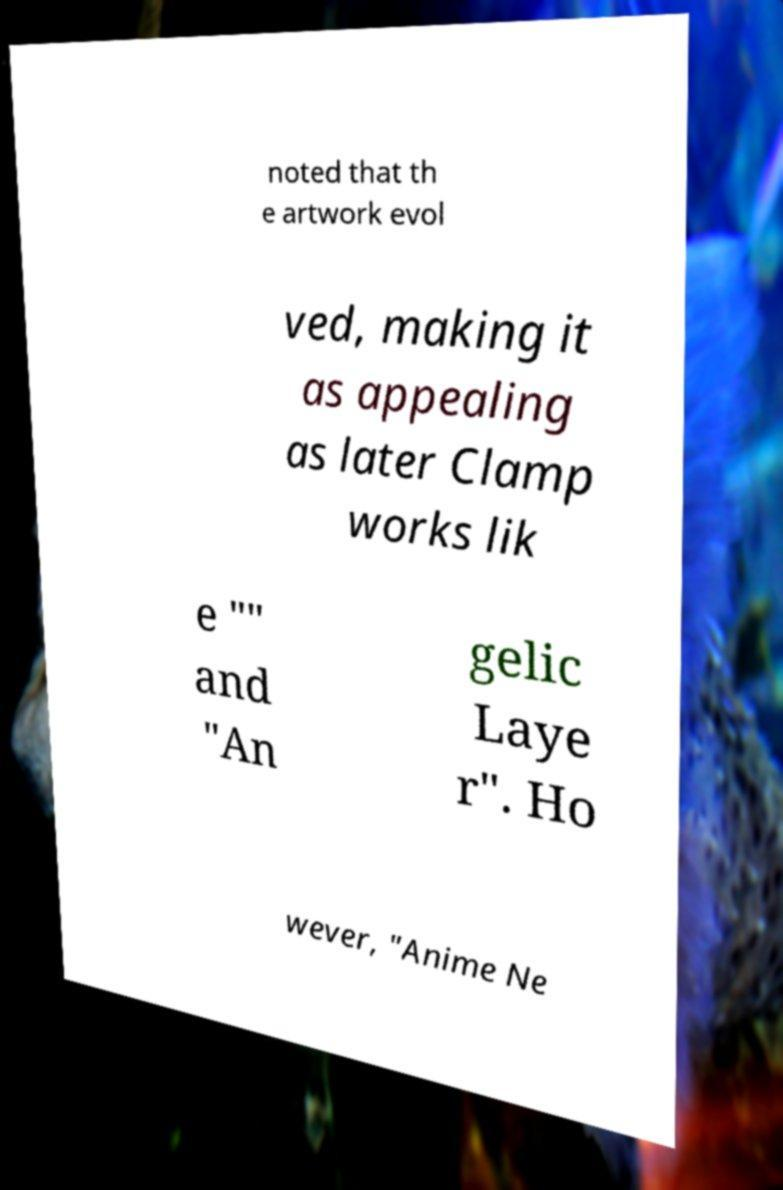What messages or text are displayed in this image? I need them in a readable, typed format. noted that th e artwork evol ved, making it as appealing as later Clamp works lik e "" and "An gelic Laye r". Ho wever, "Anime Ne 